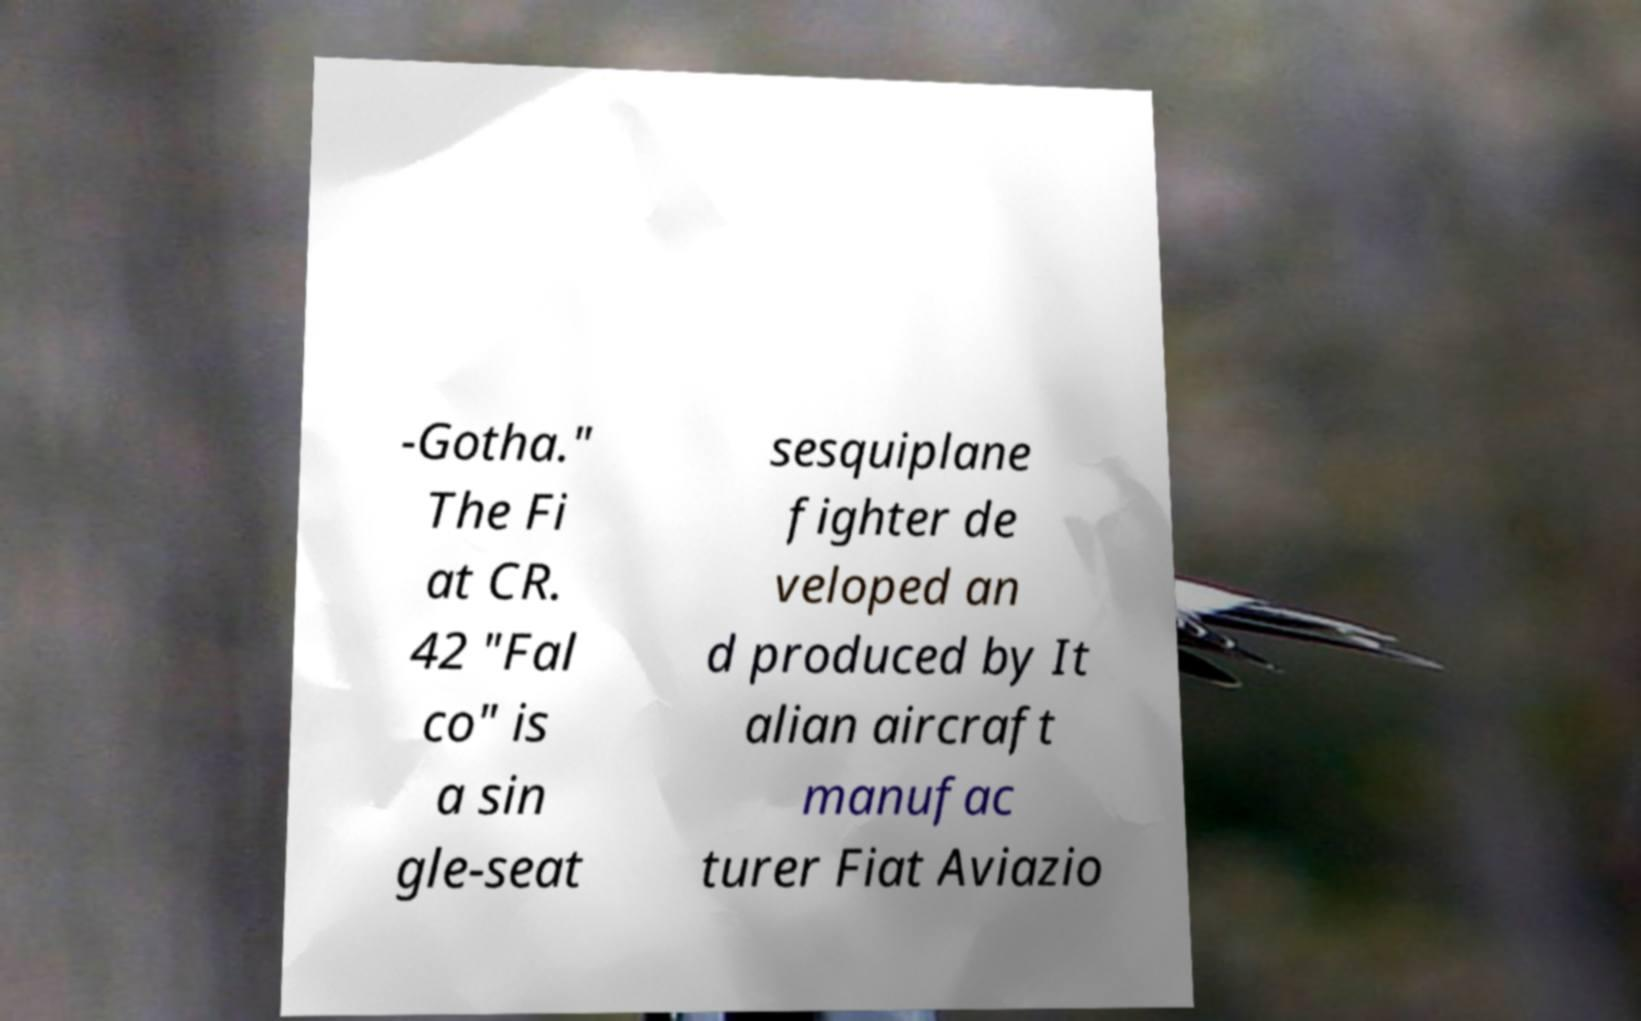Could you assist in decoding the text presented in this image and type it out clearly? -Gotha." The Fi at CR. 42 "Fal co" is a sin gle-seat sesquiplane fighter de veloped an d produced by It alian aircraft manufac turer Fiat Aviazio 